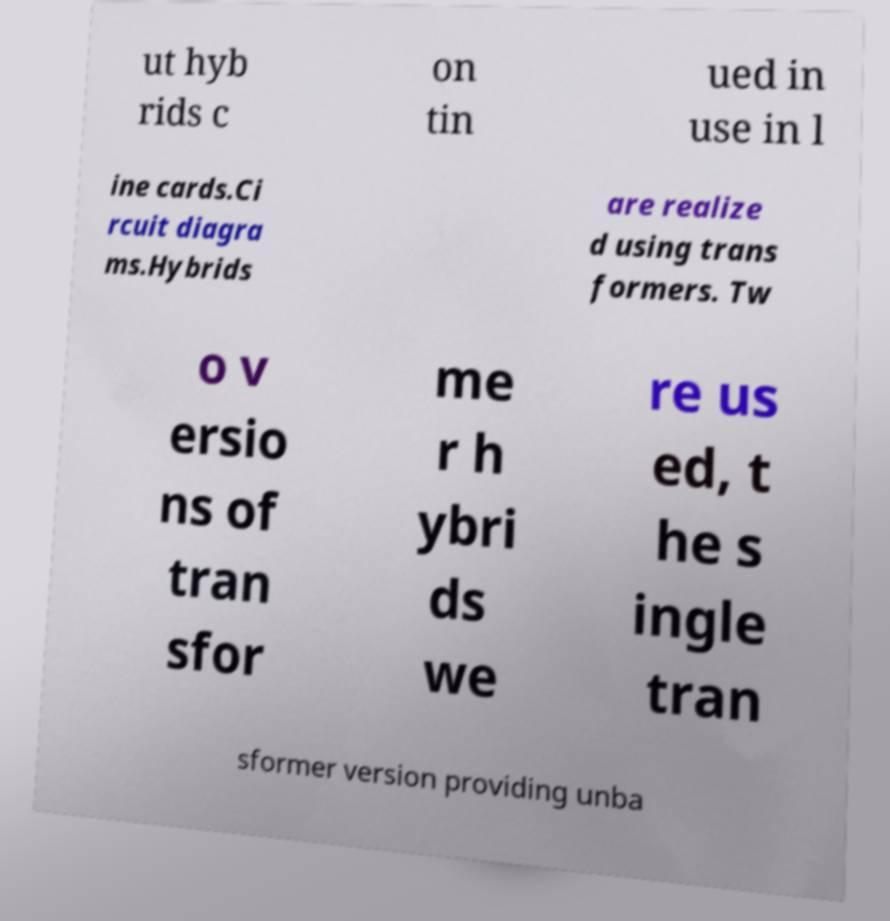Could you assist in decoding the text presented in this image and type it out clearly? ut hyb rids c on tin ued in use in l ine cards.Ci rcuit diagra ms.Hybrids are realize d using trans formers. Tw o v ersio ns of tran sfor me r h ybri ds we re us ed, t he s ingle tran sformer version providing unba 